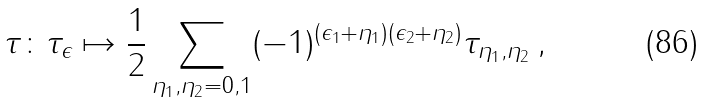Convert formula to latex. <formula><loc_0><loc_0><loc_500><loc_500>\tau \colon \tau _ { \epsilon } \mapsto \frac { 1 } { 2 } \sum _ { \eta _ { 1 } , \eta _ { 2 } = 0 , 1 } ( - 1 ) ^ { ( \epsilon _ { 1 } + \eta _ { 1 } ) ( \epsilon _ { 2 } + \eta _ { 2 } ) } \tau _ { \eta _ { 1 } , \eta _ { 2 } } \, ,</formula> 